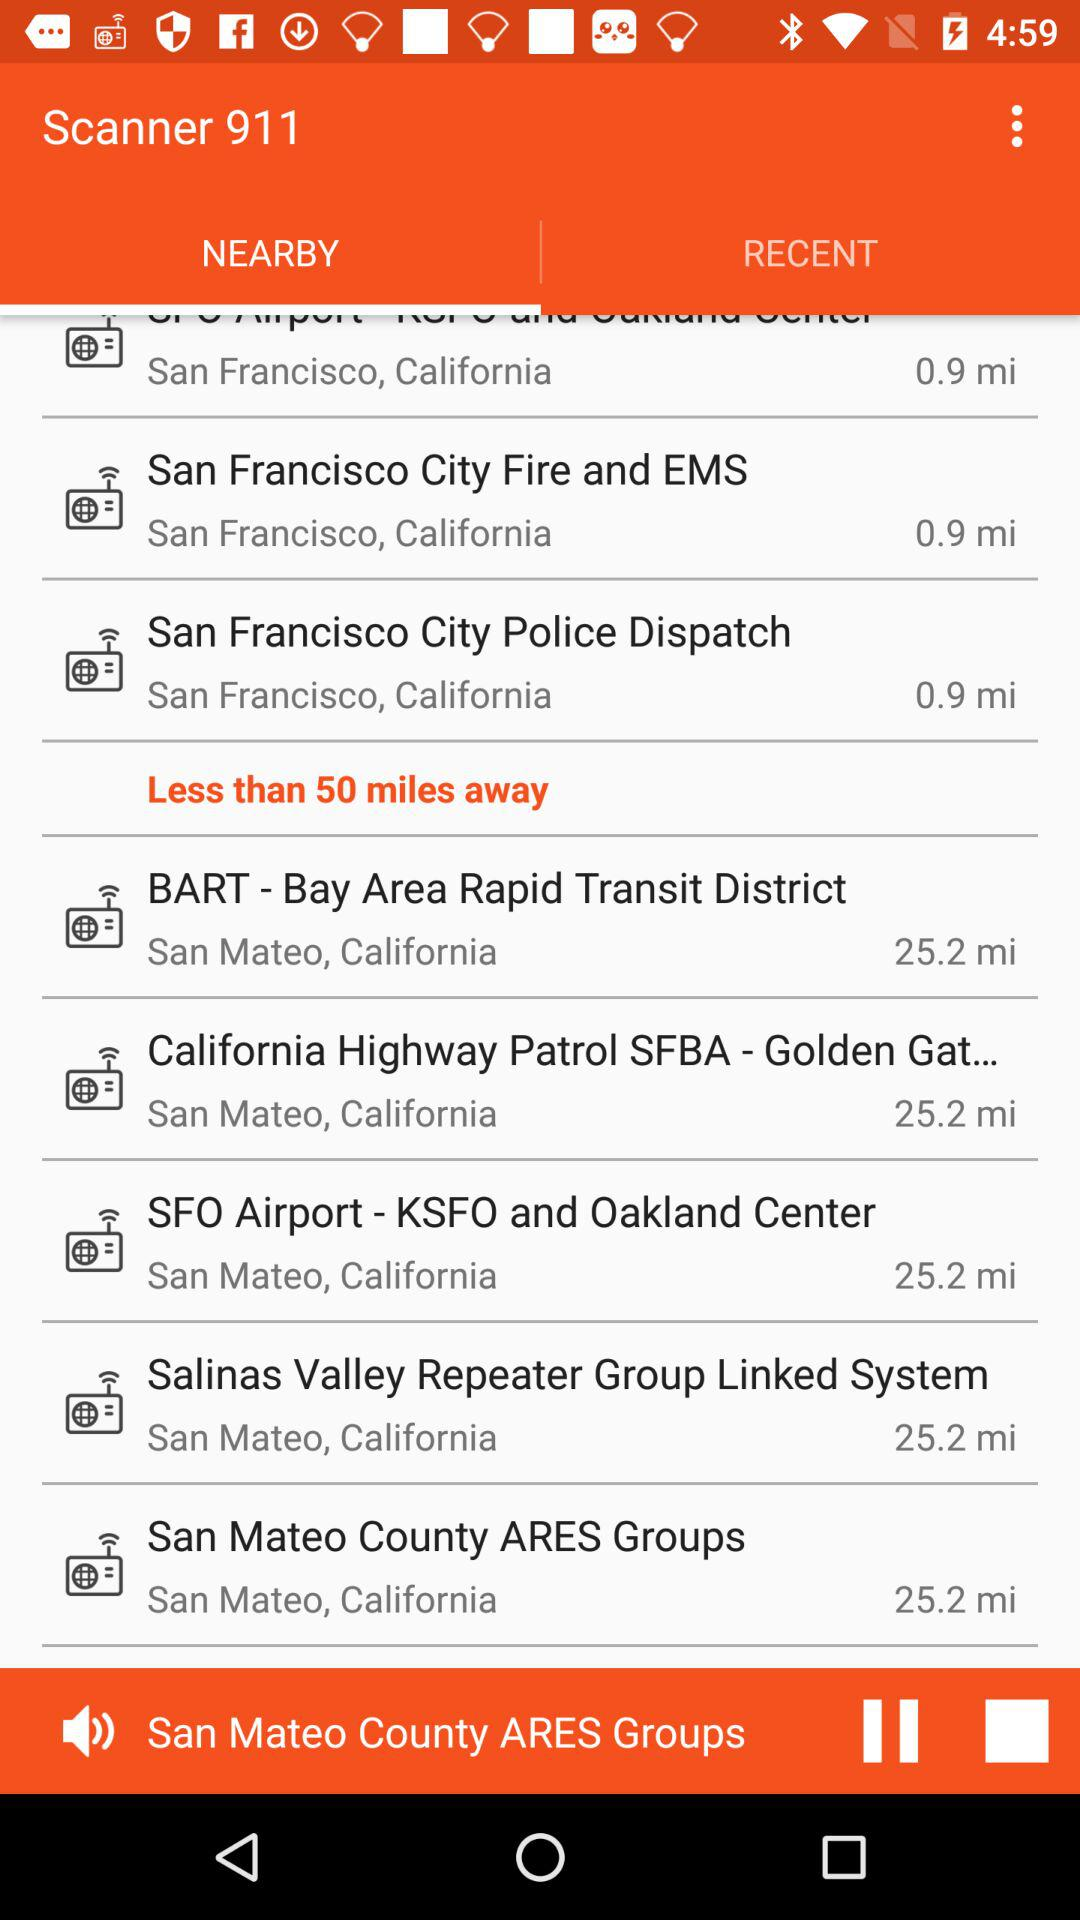Which location application is showing?
When the provided information is insufficient, respond with <no answer>. <no answer> 